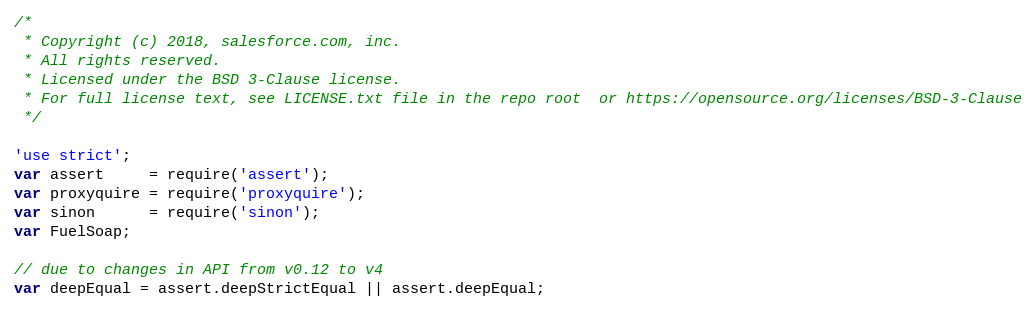Convert code to text. <code><loc_0><loc_0><loc_500><loc_500><_JavaScript_>/*
 * Copyright (c) 2018, salesforce.com, inc.
 * All rights reserved.
 * Licensed under the BSD 3-Clause license.
 * For full license text, see LICENSE.txt file in the repo root  or https://opensource.org/licenses/BSD-3-Clause
 */

'use strict';
var assert     = require('assert');
var proxyquire = require('proxyquire');
var sinon      = require('sinon');
var FuelSoap;

// due to changes in API from v0.12 to v4
var deepEqual = assert.deepStrictEqual || assert.deepEqual;
</code> 